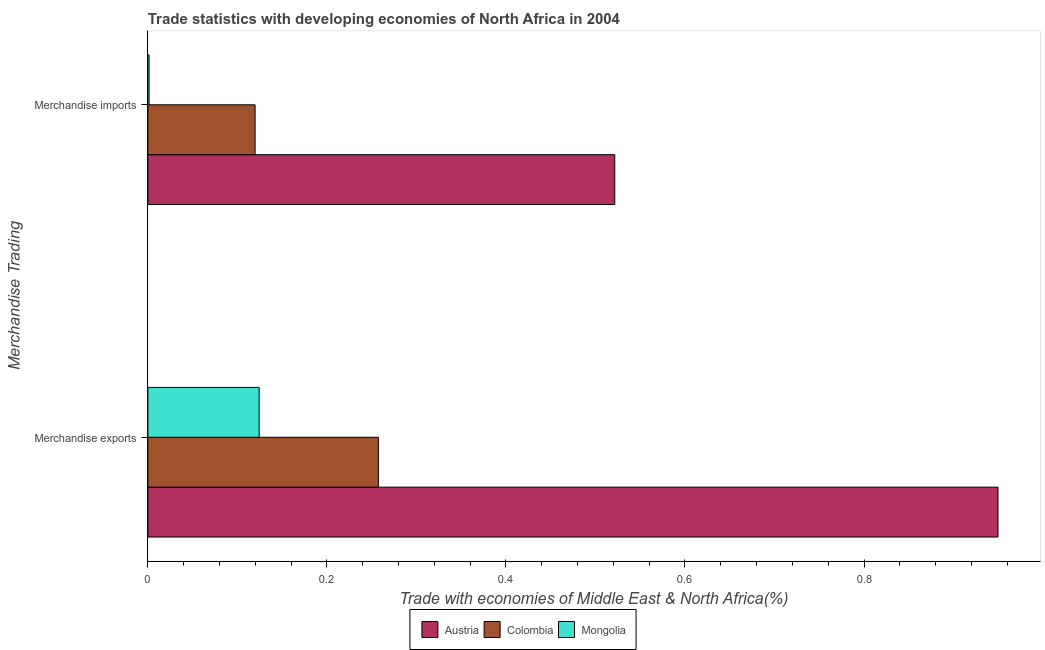Are the number of bars per tick equal to the number of legend labels?
Your answer should be very brief. Yes. Are the number of bars on each tick of the Y-axis equal?
Offer a terse response. Yes. How many bars are there on the 2nd tick from the top?
Give a very brief answer. 3. What is the label of the 1st group of bars from the top?
Provide a succinct answer. Merchandise imports. What is the merchandise imports in Colombia?
Your answer should be compact. 0.12. Across all countries, what is the maximum merchandise exports?
Give a very brief answer. 0.95. Across all countries, what is the minimum merchandise imports?
Offer a very short reply. 0. In which country was the merchandise imports maximum?
Offer a terse response. Austria. In which country was the merchandise exports minimum?
Your answer should be compact. Mongolia. What is the total merchandise imports in the graph?
Give a very brief answer. 0.64. What is the difference between the merchandise exports in Austria and that in Colombia?
Your answer should be very brief. 0.69. What is the difference between the merchandise exports in Colombia and the merchandise imports in Austria?
Ensure brevity in your answer.  -0.26. What is the average merchandise exports per country?
Provide a short and direct response. 0.44. What is the difference between the merchandise imports and merchandise exports in Colombia?
Ensure brevity in your answer.  -0.14. What is the ratio of the merchandise imports in Austria to that in Mongolia?
Make the answer very short. 388.06. Is the merchandise imports in Colombia less than that in Mongolia?
Make the answer very short. No. In how many countries, is the merchandise exports greater than the average merchandise exports taken over all countries?
Offer a terse response. 1. What does the 3rd bar from the top in Merchandise exports represents?
Make the answer very short. Austria. How many bars are there?
Make the answer very short. 6. Are all the bars in the graph horizontal?
Your response must be concise. Yes. Are the values on the major ticks of X-axis written in scientific E-notation?
Offer a terse response. No. Does the graph contain any zero values?
Your answer should be very brief. No. How are the legend labels stacked?
Provide a short and direct response. Horizontal. What is the title of the graph?
Keep it short and to the point. Trade statistics with developing economies of North Africa in 2004. Does "Somalia" appear as one of the legend labels in the graph?
Your answer should be very brief. No. What is the label or title of the X-axis?
Offer a terse response. Trade with economies of Middle East & North Africa(%). What is the label or title of the Y-axis?
Give a very brief answer. Merchandise Trading. What is the Trade with economies of Middle East & North Africa(%) in Austria in Merchandise exports?
Keep it short and to the point. 0.95. What is the Trade with economies of Middle East & North Africa(%) of Colombia in Merchandise exports?
Make the answer very short. 0.26. What is the Trade with economies of Middle East & North Africa(%) in Mongolia in Merchandise exports?
Provide a succinct answer. 0.12. What is the Trade with economies of Middle East & North Africa(%) in Austria in Merchandise imports?
Give a very brief answer. 0.52. What is the Trade with economies of Middle East & North Africa(%) of Colombia in Merchandise imports?
Provide a succinct answer. 0.12. What is the Trade with economies of Middle East & North Africa(%) in Mongolia in Merchandise imports?
Your response must be concise. 0. Across all Merchandise Trading, what is the maximum Trade with economies of Middle East & North Africa(%) of Austria?
Your answer should be very brief. 0.95. Across all Merchandise Trading, what is the maximum Trade with economies of Middle East & North Africa(%) of Colombia?
Provide a short and direct response. 0.26. Across all Merchandise Trading, what is the maximum Trade with economies of Middle East & North Africa(%) of Mongolia?
Provide a short and direct response. 0.12. Across all Merchandise Trading, what is the minimum Trade with economies of Middle East & North Africa(%) in Austria?
Offer a very short reply. 0.52. Across all Merchandise Trading, what is the minimum Trade with economies of Middle East & North Africa(%) of Colombia?
Ensure brevity in your answer.  0.12. Across all Merchandise Trading, what is the minimum Trade with economies of Middle East & North Africa(%) of Mongolia?
Keep it short and to the point. 0. What is the total Trade with economies of Middle East & North Africa(%) in Austria in the graph?
Offer a terse response. 1.47. What is the total Trade with economies of Middle East & North Africa(%) in Colombia in the graph?
Offer a terse response. 0.38. What is the total Trade with economies of Middle East & North Africa(%) in Mongolia in the graph?
Your response must be concise. 0.13. What is the difference between the Trade with economies of Middle East & North Africa(%) of Austria in Merchandise exports and that in Merchandise imports?
Ensure brevity in your answer.  0.43. What is the difference between the Trade with economies of Middle East & North Africa(%) in Colombia in Merchandise exports and that in Merchandise imports?
Ensure brevity in your answer.  0.14. What is the difference between the Trade with economies of Middle East & North Africa(%) of Mongolia in Merchandise exports and that in Merchandise imports?
Provide a succinct answer. 0.12. What is the difference between the Trade with economies of Middle East & North Africa(%) of Austria in Merchandise exports and the Trade with economies of Middle East & North Africa(%) of Colombia in Merchandise imports?
Offer a very short reply. 0.83. What is the difference between the Trade with economies of Middle East & North Africa(%) of Austria in Merchandise exports and the Trade with economies of Middle East & North Africa(%) of Mongolia in Merchandise imports?
Give a very brief answer. 0.95. What is the difference between the Trade with economies of Middle East & North Africa(%) of Colombia in Merchandise exports and the Trade with economies of Middle East & North Africa(%) of Mongolia in Merchandise imports?
Give a very brief answer. 0.26. What is the average Trade with economies of Middle East & North Africa(%) of Austria per Merchandise Trading?
Your answer should be very brief. 0.74. What is the average Trade with economies of Middle East & North Africa(%) of Colombia per Merchandise Trading?
Your answer should be very brief. 0.19. What is the average Trade with economies of Middle East & North Africa(%) of Mongolia per Merchandise Trading?
Offer a very short reply. 0.06. What is the difference between the Trade with economies of Middle East & North Africa(%) of Austria and Trade with economies of Middle East & North Africa(%) of Colombia in Merchandise exports?
Ensure brevity in your answer.  0.69. What is the difference between the Trade with economies of Middle East & North Africa(%) of Austria and Trade with economies of Middle East & North Africa(%) of Mongolia in Merchandise exports?
Give a very brief answer. 0.83. What is the difference between the Trade with economies of Middle East & North Africa(%) in Colombia and Trade with economies of Middle East & North Africa(%) in Mongolia in Merchandise exports?
Offer a very short reply. 0.13. What is the difference between the Trade with economies of Middle East & North Africa(%) in Austria and Trade with economies of Middle East & North Africa(%) in Colombia in Merchandise imports?
Offer a terse response. 0.4. What is the difference between the Trade with economies of Middle East & North Africa(%) in Austria and Trade with economies of Middle East & North Africa(%) in Mongolia in Merchandise imports?
Make the answer very short. 0.52. What is the difference between the Trade with economies of Middle East & North Africa(%) of Colombia and Trade with economies of Middle East & North Africa(%) of Mongolia in Merchandise imports?
Your answer should be very brief. 0.12. What is the ratio of the Trade with economies of Middle East & North Africa(%) of Austria in Merchandise exports to that in Merchandise imports?
Provide a short and direct response. 1.82. What is the ratio of the Trade with economies of Middle East & North Africa(%) in Colombia in Merchandise exports to that in Merchandise imports?
Provide a succinct answer. 2.15. What is the ratio of the Trade with economies of Middle East & North Africa(%) of Mongolia in Merchandise exports to that in Merchandise imports?
Your answer should be very brief. 92.5. What is the difference between the highest and the second highest Trade with economies of Middle East & North Africa(%) of Austria?
Give a very brief answer. 0.43. What is the difference between the highest and the second highest Trade with economies of Middle East & North Africa(%) in Colombia?
Your answer should be compact. 0.14. What is the difference between the highest and the second highest Trade with economies of Middle East & North Africa(%) of Mongolia?
Ensure brevity in your answer.  0.12. What is the difference between the highest and the lowest Trade with economies of Middle East & North Africa(%) of Austria?
Your answer should be very brief. 0.43. What is the difference between the highest and the lowest Trade with economies of Middle East & North Africa(%) in Colombia?
Provide a succinct answer. 0.14. What is the difference between the highest and the lowest Trade with economies of Middle East & North Africa(%) of Mongolia?
Offer a terse response. 0.12. 